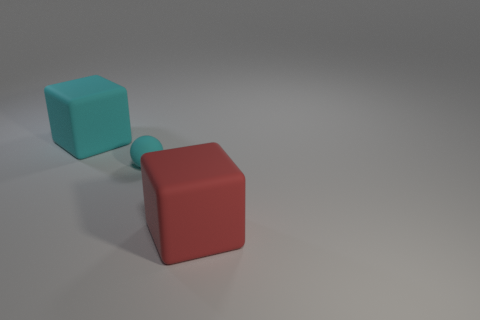Is the size of the rubber cube that is left of the large red rubber thing the same as the red object that is in front of the small ball? Yes, the size of the turquoise rubber cube on the left appears to match the size of the large red cube in the foreground, suggesting they are the same in volume and dimensions. 